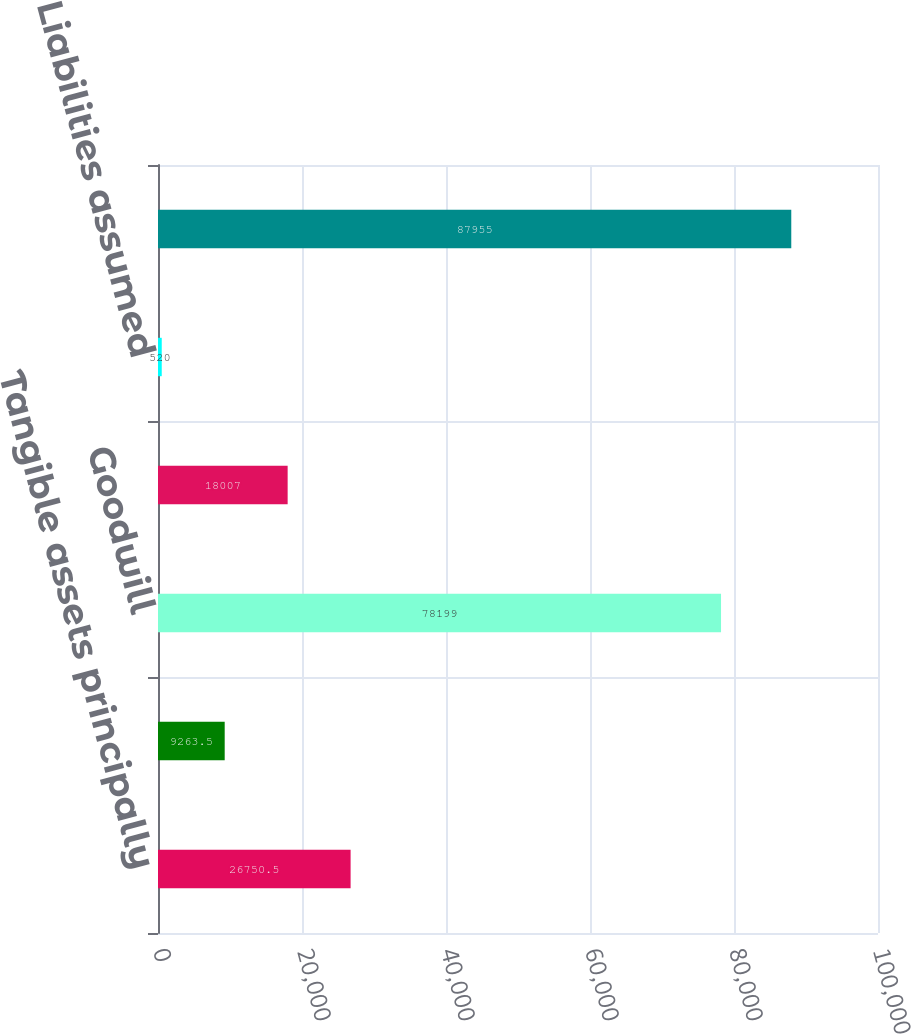Convert chart to OTSL. <chart><loc_0><loc_0><loc_500><loc_500><bar_chart><fcel>Tangible assets principally<fcel>Amortizable intangible assets<fcel>Goodwill<fcel>Noncontrolling interests<fcel>Liabilities assumed<fcel>Aggregate purchase cost<nl><fcel>26750.5<fcel>9263.5<fcel>78199<fcel>18007<fcel>520<fcel>87955<nl></chart> 